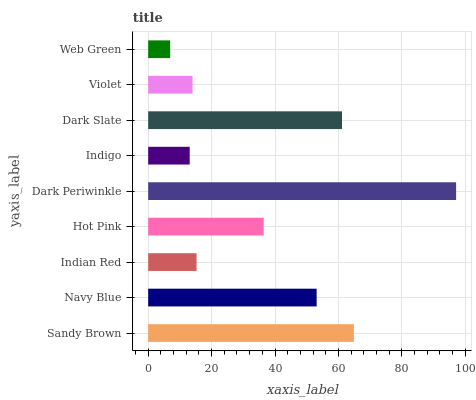Is Web Green the minimum?
Answer yes or no. Yes. Is Dark Periwinkle the maximum?
Answer yes or no. Yes. Is Navy Blue the minimum?
Answer yes or no. No. Is Navy Blue the maximum?
Answer yes or no. No. Is Sandy Brown greater than Navy Blue?
Answer yes or no. Yes. Is Navy Blue less than Sandy Brown?
Answer yes or no. Yes. Is Navy Blue greater than Sandy Brown?
Answer yes or no. No. Is Sandy Brown less than Navy Blue?
Answer yes or no. No. Is Hot Pink the high median?
Answer yes or no. Yes. Is Hot Pink the low median?
Answer yes or no. Yes. Is Sandy Brown the high median?
Answer yes or no. No. Is Dark Periwinkle the low median?
Answer yes or no. No. 